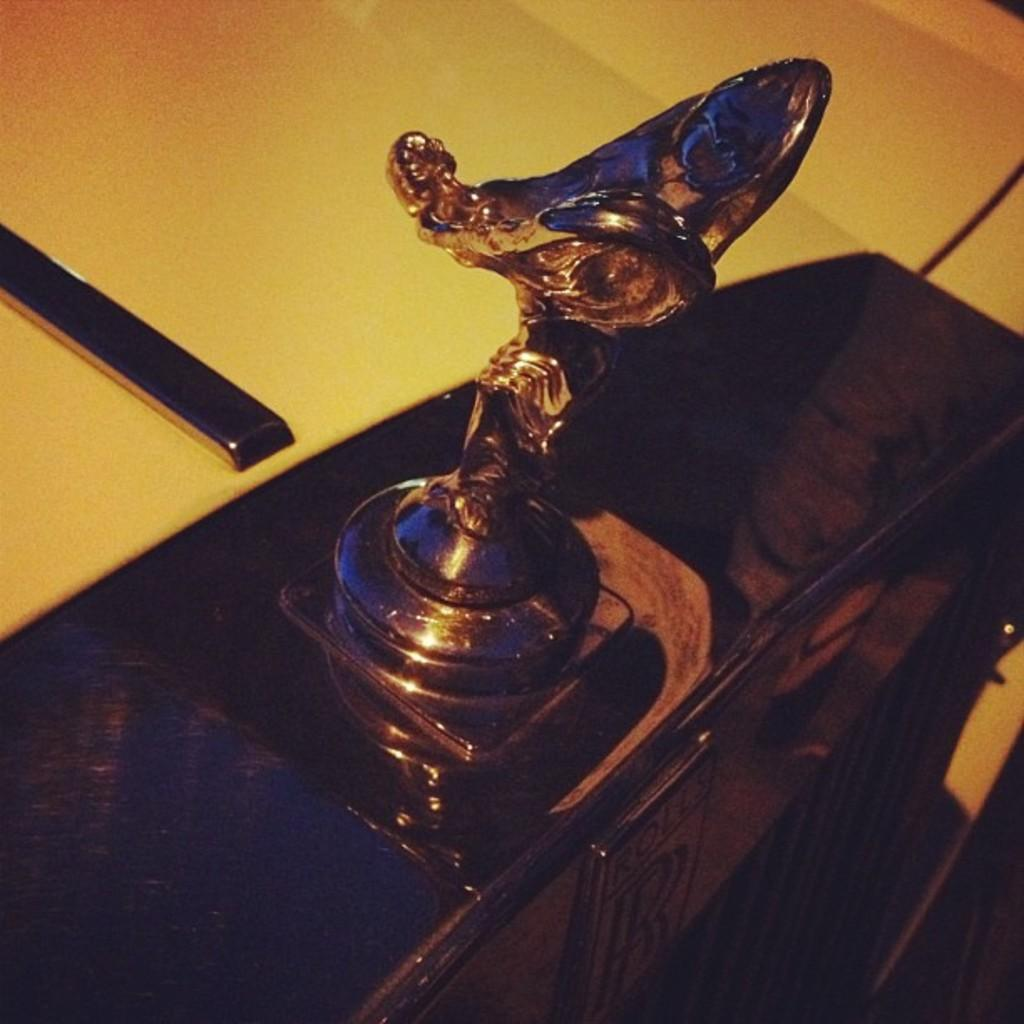What is the main subject of the picture? The main subject of the picture is a vehicle. What can be seen on the vehicle? There is text and a sculpture on the vehicle. Where is the playground located in the image? There is no playground present in the image. What type of fire can be seen on the vehicle? There is no fire present on the vehicle in the image. 